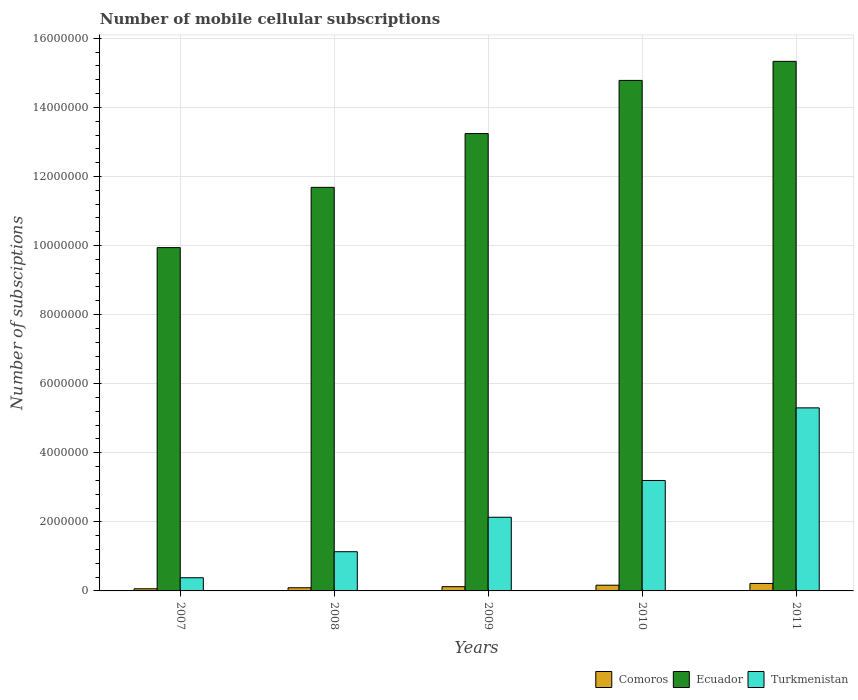How many groups of bars are there?
Give a very brief answer. 5. Are the number of bars per tick equal to the number of legend labels?
Offer a very short reply. Yes. Are the number of bars on each tick of the X-axis equal?
Your answer should be compact. Yes. How many bars are there on the 4th tick from the left?
Provide a short and direct response. 3. How many bars are there on the 4th tick from the right?
Your response must be concise. 3. What is the number of mobile cellular subscriptions in Comoros in 2009?
Make the answer very short. 1.23e+05. Across all years, what is the maximum number of mobile cellular subscriptions in Ecuador?
Offer a terse response. 1.53e+07. Across all years, what is the minimum number of mobile cellular subscriptions in Turkmenistan?
Keep it short and to the point. 3.82e+05. What is the total number of mobile cellular subscriptions in Comoros in the graph?
Ensure brevity in your answer.  6.58e+05. What is the difference between the number of mobile cellular subscriptions in Ecuador in 2008 and that in 2011?
Offer a terse response. -3.65e+06. What is the difference between the number of mobile cellular subscriptions in Comoros in 2008 and the number of mobile cellular subscriptions in Turkmenistan in 2007?
Your response must be concise. -2.90e+05. What is the average number of mobile cellular subscriptions in Turkmenistan per year?
Your answer should be very brief. 2.43e+06. In the year 2010, what is the difference between the number of mobile cellular subscriptions in Comoros and number of mobile cellular subscriptions in Ecuador?
Your answer should be very brief. -1.46e+07. What is the ratio of the number of mobile cellular subscriptions in Comoros in 2007 to that in 2011?
Make the answer very short. 0.29. What is the difference between the highest and the second highest number of mobile cellular subscriptions in Comoros?
Your response must be concise. 5.12e+04. What is the difference between the highest and the lowest number of mobile cellular subscriptions in Ecuador?
Make the answer very short. 5.39e+06. In how many years, is the number of mobile cellular subscriptions in Ecuador greater than the average number of mobile cellular subscriptions in Ecuador taken over all years?
Provide a short and direct response. 3. Is the sum of the number of mobile cellular subscriptions in Turkmenistan in 2008 and 2010 greater than the maximum number of mobile cellular subscriptions in Comoros across all years?
Offer a terse response. Yes. What does the 3rd bar from the left in 2011 represents?
Your answer should be compact. Turkmenistan. What does the 2nd bar from the right in 2010 represents?
Offer a terse response. Ecuador. How many years are there in the graph?
Provide a short and direct response. 5. Are the values on the major ticks of Y-axis written in scientific E-notation?
Offer a terse response. No. Does the graph contain any zero values?
Your answer should be compact. No. What is the title of the graph?
Offer a very short reply. Number of mobile cellular subscriptions. Does "High income: nonOECD" appear as one of the legend labels in the graph?
Ensure brevity in your answer.  No. What is the label or title of the X-axis?
Give a very brief answer. Years. What is the label or title of the Y-axis?
Ensure brevity in your answer.  Number of subsciptions. What is the Number of subsciptions in Comoros in 2007?
Keep it short and to the point. 6.21e+04. What is the Number of subsciptions of Ecuador in 2007?
Your response must be concise. 9.94e+06. What is the Number of subsciptions in Turkmenistan in 2007?
Make the answer very short. 3.82e+05. What is the Number of subsciptions in Comoros in 2008?
Your response must be concise. 9.17e+04. What is the Number of subsciptions in Ecuador in 2008?
Offer a very short reply. 1.17e+07. What is the Number of subsciptions of Turkmenistan in 2008?
Provide a succinct answer. 1.14e+06. What is the Number of subsciptions of Comoros in 2009?
Your answer should be very brief. 1.23e+05. What is the Number of subsciptions of Ecuador in 2009?
Your answer should be compact. 1.32e+07. What is the Number of subsciptions of Turkmenistan in 2009?
Your answer should be compact. 2.13e+06. What is the Number of subsciptions in Comoros in 2010?
Provide a succinct answer. 1.65e+05. What is the Number of subsciptions of Ecuador in 2010?
Offer a very short reply. 1.48e+07. What is the Number of subsciptions in Turkmenistan in 2010?
Offer a terse response. 3.20e+06. What is the Number of subsciptions in Comoros in 2011?
Your response must be concise. 2.16e+05. What is the Number of subsciptions in Ecuador in 2011?
Ensure brevity in your answer.  1.53e+07. What is the Number of subsciptions in Turkmenistan in 2011?
Make the answer very short. 5.30e+06. Across all years, what is the maximum Number of subsciptions in Comoros?
Keep it short and to the point. 2.16e+05. Across all years, what is the maximum Number of subsciptions in Ecuador?
Give a very brief answer. 1.53e+07. Across all years, what is the maximum Number of subsciptions of Turkmenistan?
Keep it short and to the point. 5.30e+06. Across all years, what is the minimum Number of subsciptions of Comoros?
Your answer should be very brief. 6.21e+04. Across all years, what is the minimum Number of subsciptions in Ecuador?
Your answer should be very brief. 9.94e+06. Across all years, what is the minimum Number of subsciptions of Turkmenistan?
Offer a very short reply. 3.82e+05. What is the total Number of subsciptions of Comoros in the graph?
Keep it short and to the point. 6.58e+05. What is the total Number of subsciptions in Ecuador in the graph?
Provide a short and direct response. 6.50e+07. What is the total Number of subsciptions of Turkmenistan in the graph?
Your answer should be very brief. 1.21e+07. What is the difference between the Number of subsciptions of Comoros in 2007 and that in 2008?
Provide a succinct answer. -2.96e+04. What is the difference between the Number of subsciptions of Ecuador in 2007 and that in 2008?
Your answer should be very brief. -1.74e+06. What is the difference between the Number of subsciptions in Turkmenistan in 2007 and that in 2008?
Offer a very short reply. -7.53e+05. What is the difference between the Number of subsciptions in Comoros in 2007 and that in 2009?
Your response must be concise. -6.05e+04. What is the difference between the Number of subsciptions of Ecuador in 2007 and that in 2009?
Your response must be concise. -3.30e+06. What is the difference between the Number of subsciptions in Turkmenistan in 2007 and that in 2009?
Your answer should be compact. -1.75e+06. What is the difference between the Number of subsciptions in Comoros in 2007 and that in 2010?
Make the answer very short. -1.03e+05. What is the difference between the Number of subsciptions in Ecuador in 2007 and that in 2010?
Ensure brevity in your answer.  -4.84e+06. What is the difference between the Number of subsciptions in Turkmenistan in 2007 and that in 2010?
Offer a very short reply. -2.82e+06. What is the difference between the Number of subsciptions of Comoros in 2007 and that in 2011?
Offer a very short reply. -1.54e+05. What is the difference between the Number of subsciptions in Ecuador in 2007 and that in 2011?
Provide a short and direct response. -5.39e+06. What is the difference between the Number of subsciptions in Turkmenistan in 2007 and that in 2011?
Your response must be concise. -4.92e+06. What is the difference between the Number of subsciptions of Comoros in 2008 and that in 2009?
Keep it short and to the point. -3.09e+04. What is the difference between the Number of subsciptions in Ecuador in 2008 and that in 2009?
Provide a succinct answer. -1.56e+06. What is the difference between the Number of subsciptions in Turkmenistan in 2008 and that in 2009?
Your answer should be very brief. -9.98e+05. What is the difference between the Number of subsciptions of Comoros in 2008 and that in 2010?
Your answer should be compact. -7.35e+04. What is the difference between the Number of subsciptions of Ecuador in 2008 and that in 2010?
Your response must be concise. -3.10e+06. What is the difference between the Number of subsciptions of Turkmenistan in 2008 and that in 2010?
Provide a succinct answer. -2.06e+06. What is the difference between the Number of subsciptions of Comoros in 2008 and that in 2011?
Give a very brief answer. -1.25e+05. What is the difference between the Number of subsciptions of Ecuador in 2008 and that in 2011?
Offer a very short reply. -3.65e+06. What is the difference between the Number of subsciptions in Turkmenistan in 2008 and that in 2011?
Make the answer very short. -4.16e+06. What is the difference between the Number of subsciptions in Comoros in 2009 and that in 2010?
Ensure brevity in your answer.  -4.27e+04. What is the difference between the Number of subsciptions in Ecuador in 2009 and that in 2010?
Keep it short and to the point. -1.54e+06. What is the difference between the Number of subsciptions of Turkmenistan in 2009 and that in 2010?
Make the answer very short. -1.06e+06. What is the difference between the Number of subsciptions in Comoros in 2009 and that in 2011?
Give a very brief answer. -9.38e+04. What is the difference between the Number of subsciptions of Ecuador in 2009 and that in 2011?
Offer a very short reply. -2.09e+06. What is the difference between the Number of subsciptions in Turkmenistan in 2009 and that in 2011?
Give a very brief answer. -3.17e+06. What is the difference between the Number of subsciptions of Comoros in 2010 and that in 2011?
Your answer should be very brief. -5.12e+04. What is the difference between the Number of subsciptions in Ecuador in 2010 and that in 2011?
Your answer should be very brief. -5.52e+05. What is the difference between the Number of subsciptions in Turkmenistan in 2010 and that in 2011?
Your response must be concise. -2.10e+06. What is the difference between the Number of subsciptions in Comoros in 2007 and the Number of subsciptions in Ecuador in 2008?
Offer a very short reply. -1.16e+07. What is the difference between the Number of subsciptions of Comoros in 2007 and the Number of subsciptions of Turkmenistan in 2008?
Give a very brief answer. -1.07e+06. What is the difference between the Number of subsciptions in Ecuador in 2007 and the Number of subsciptions in Turkmenistan in 2008?
Your answer should be very brief. 8.80e+06. What is the difference between the Number of subsciptions of Comoros in 2007 and the Number of subsciptions of Ecuador in 2009?
Keep it short and to the point. -1.32e+07. What is the difference between the Number of subsciptions of Comoros in 2007 and the Number of subsciptions of Turkmenistan in 2009?
Make the answer very short. -2.07e+06. What is the difference between the Number of subsciptions of Ecuador in 2007 and the Number of subsciptions of Turkmenistan in 2009?
Make the answer very short. 7.81e+06. What is the difference between the Number of subsciptions in Comoros in 2007 and the Number of subsciptions in Ecuador in 2010?
Offer a very short reply. -1.47e+07. What is the difference between the Number of subsciptions in Comoros in 2007 and the Number of subsciptions in Turkmenistan in 2010?
Offer a very short reply. -3.14e+06. What is the difference between the Number of subsciptions in Ecuador in 2007 and the Number of subsciptions in Turkmenistan in 2010?
Offer a terse response. 6.74e+06. What is the difference between the Number of subsciptions of Comoros in 2007 and the Number of subsciptions of Ecuador in 2011?
Ensure brevity in your answer.  -1.53e+07. What is the difference between the Number of subsciptions of Comoros in 2007 and the Number of subsciptions of Turkmenistan in 2011?
Your response must be concise. -5.24e+06. What is the difference between the Number of subsciptions of Ecuador in 2007 and the Number of subsciptions of Turkmenistan in 2011?
Keep it short and to the point. 4.64e+06. What is the difference between the Number of subsciptions in Comoros in 2008 and the Number of subsciptions in Ecuador in 2009?
Make the answer very short. -1.32e+07. What is the difference between the Number of subsciptions in Comoros in 2008 and the Number of subsciptions in Turkmenistan in 2009?
Give a very brief answer. -2.04e+06. What is the difference between the Number of subsciptions of Ecuador in 2008 and the Number of subsciptions of Turkmenistan in 2009?
Your response must be concise. 9.55e+06. What is the difference between the Number of subsciptions of Comoros in 2008 and the Number of subsciptions of Ecuador in 2010?
Your answer should be compact. -1.47e+07. What is the difference between the Number of subsciptions in Comoros in 2008 and the Number of subsciptions in Turkmenistan in 2010?
Your answer should be compact. -3.11e+06. What is the difference between the Number of subsciptions of Ecuador in 2008 and the Number of subsciptions of Turkmenistan in 2010?
Your answer should be very brief. 8.49e+06. What is the difference between the Number of subsciptions in Comoros in 2008 and the Number of subsciptions in Ecuador in 2011?
Offer a terse response. -1.52e+07. What is the difference between the Number of subsciptions in Comoros in 2008 and the Number of subsciptions in Turkmenistan in 2011?
Ensure brevity in your answer.  -5.21e+06. What is the difference between the Number of subsciptions in Ecuador in 2008 and the Number of subsciptions in Turkmenistan in 2011?
Provide a succinct answer. 6.38e+06. What is the difference between the Number of subsciptions of Comoros in 2009 and the Number of subsciptions of Ecuador in 2010?
Ensure brevity in your answer.  -1.47e+07. What is the difference between the Number of subsciptions of Comoros in 2009 and the Number of subsciptions of Turkmenistan in 2010?
Provide a short and direct response. -3.08e+06. What is the difference between the Number of subsciptions of Ecuador in 2009 and the Number of subsciptions of Turkmenistan in 2010?
Your answer should be compact. 1.00e+07. What is the difference between the Number of subsciptions in Comoros in 2009 and the Number of subsciptions in Ecuador in 2011?
Provide a short and direct response. -1.52e+07. What is the difference between the Number of subsciptions in Comoros in 2009 and the Number of subsciptions in Turkmenistan in 2011?
Provide a succinct answer. -5.18e+06. What is the difference between the Number of subsciptions of Ecuador in 2009 and the Number of subsciptions of Turkmenistan in 2011?
Offer a terse response. 7.94e+06. What is the difference between the Number of subsciptions of Comoros in 2010 and the Number of subsciptions of Ecuador in 2011?
Make the answer very short. -1.52e+07. What is the difference between the Number of subsciptions of Comoros in 2010 and the Number of subsciptions of Turkmenistan in 2011?
Your answer should be very brief. -5.13e+06. What is the difference between the Number of subsciptions in Ecuador in 2010 and the Number of subsciptions in Turkmenistan in 2011?
Give a very brief answer. 9.48e+06. What is the average Number of subsciptions in Comoros per year?
Make the answer very short. 1.32e+05. What is the average Number of subsciptions of Ecuador per year?
Your answer should be compact. 1.30e+07. What is the average Number of subsciptions in Turkmenistan per year?
Your response must be concise. 2.43e+06. In the year 2007, what is the difference between the Number of subsciptions of Comoros and Number of subsciptions of Ecuador?
Your answer should be very brief. -9.88e+06. In the year 2007, what is the difference between the Number of subsciptions in Comoros and Number of subsciptions in Turkmenistan?
Ensure brevity in your answer.  -3.20e+05. In the year 2007, what is the difference between the Number of subsciptions of Ecuador and Number of subsciptions of Turkmenistan?
Give a very brief answer. 9.56e+06. In the year 2008, what is the difference between the Number of subsciptions of Comoros and Number of subsciptions of Ecuador?
Provide a succinct answer. -1.16e+07. In the year 2008, what is the difference between the Number of subsciptions in Comoros and Number of subsciptions in Turkmenistan?
Provide a succinct answer. -1.04e+06. In the year 2008, what is the difference between the Number of subsciptions of Ecuador and Number of subsciptions of Turkmenistan?
Make the answer very short. 1.05e+07. In the year 2009, what is the difference between the Number of subsciptions in Comoros and Number of subsciptions in Ecuador?
Your answer should be very brief. -1.31e+07. In the year 2009, what is the difference between the Number of subsciptions of Comoros and Number of subsciptions of Turkmenistan?
Offer a terse response. -2.01e+06. In the year 2009, what is the difference between the Number of subsciptions of Ecuador and Number of subsciptions of Turkmenistan?
Make the answer very short. 1.11e+07. In the year 2010, what is the difference between the Number of subsciptions in Comoros and Number of subsciptions in Ecuador?
Ensure brevity in your answer.  -1.46e+07. In the year 2010, what is the difference between the Number of subsciptions of Comoros and Number of subsciptions of Turkmenistan?
Offer a very short reply. -3.03e+06. In the year 2010, what is the difference between the Number of subsciptions of Ecuador and Number of subsciptions of Turkmenistan?
Ensure brevity in your answer.  1.16e+07. In the year 2011, what is the difference between the Number of subsciptions in Comoros and Number of subsciptions in Ecuador?
Offer a very short reply. -1.51e+07. In the year 2011, what is the difference between the Number of subsciptions of Comoros and Number of subsciptions of Turkmenistan?
Give a very brief answer. -5.08e+06. In the year 2011, what is the difference between the Number of subsciptions in Ecuador and Number of subsciptions in Turkmenistan?
Your answer should be very brief. 1.00e+07. What is the ratio of the Number of subsciptions in Comoros in 2007 to that in 2008?
Offer a terse response. 0.68. What is the ratio of the Number of subsciptions of Ecuador in 2007 to that in 2008?
Provide a short and direct response. 0.85. What is the ratio of the Number of subsciptions in Turkmenistan in 2007 to that in 2008?
Keep it short and to the point. 0.34. What is the ratio of the Number of subsciptions in Comoros in 2007 to that in 2009?
Give a very brief answer. 0.51. What is the ratio of the Number of subsciptions of Ecuador in 2007 to that in 2009?
Your answer should be very brief. 0.75. What is the ratio of the Number of subsciptions of Turkmenistan in 2007 to that in 2009?
Provide a short and direct response. 0.18. What is the ratio of the Number of subsciptions in Comoros in 2007 to that in 2010?
Give a very brief answer. 0.38. What is the ratio of the Number of subsciptions in Ecuador in 2007 to that in 2010?
Give a very brief answer. 0.67. What is the ratio of the Number of subsciptions of Turkmenistan in 2007 to that in 2010?
Ensure brevity in your answer.  0.12. What is the ratio of the Number of subsciptions in Comoros in 2007 to that in 2011?
Provide a short and direct response. 0.29. What is the ratio of the Number of subsciptions in Ecuador in 2007 to that in 2011?
Offer a very short reply. 0.65. What is the ratio of the Number of subsciptions in Turkmenistan in 2007 to that in 2011?
Provide a short and direct response. 0.07. What is the ratio of the Number of subsciptions of Comoros in 2008 to that in 2009?
Your response must be concise. 0.75. What is the ratio of the Number of subsciptions of Ecuador in 2008 to that in 2009?
Your answer should be compact. 0.88. What is the ratio of the Number of subsciptions of Turkmenistan in 2008 to that in 2009?
Give a very brief answer. 0.53. What is the ratio of the Number of subsciptions in Comoros in 2008 to that in 2010?
Make the answer very short. 0.56. What is the ratio of the Number of subsciptions of Ecuador in 2008 to that in 2010?
Keep it short and to the point. 0.79. What is the ratio of the Number of subsciptions in Turkmenistan in 2008 to that in 2010?
Provide a short and direct response. 0.35. What is the ratio of the Number of subsciptions of Comoros in 2008 to that in 2011?
Your answer should be compact. 0.42. What is the ratio of the Number of subsciptions in Ecuador in 2008 to that in 2011?
Your response must be concise. 0.76. What is the ratio of the Number of subsciptions of Turkmenistan in 2008 to that in 2011?
Your answer should be compact. 0.21. What is the ratio of the Number of subsciptions in Comoros in 2009 to that in 2010?
Provide a short and direct response. 0.74. What is the ratio of the Number of subsciptions of Ecuador in 2009 to that in 2010?
Give a very brief answer. 0.9. What is the ratio of the Number of subsciptions of Turkmenistan in 2009 to that in 2010?
Offer a terse response. 0.67. What is the ratio of the Number of subsciptions of Comoros in 2009 to that in 2011?
Your response must be concise. 0.57. What is the ratio of the Number of subsciptions in Ecuador in 2009 to that in 2011?
Give a very brief answer. 0.86. What is the ratio of the Number of subsciptions in Turkmenistan in 2009 to that in 2011?
Give a very brief answer. 0.4. What is the ratio of the Number of subsciptions in Comoros in 2010 to that in 2011?
Ensure brevity in your answer.  0.76. What is the ratio of the Number of subsciptions of Turkmenistan in 2010 to that in 2011?
Provide a succinct answer. 0.6. What is the difference between the highest and the second highest Number of subsciptions of Comoros?
Your answer should be compact. 5.12e+04. What is the difference between the highest and the second highest Number of subsciptions in Ecuador?
Provide a succinct answer. 5.52e+05. What is the difference between the highest and the second highest Number of subsciptions in Turkmenistan?
Provide a short and direct response. 2.10e+06. What is the difference between the highest and the lowest Number of subsciptions in Comoros?
Offer a very short reply. 1.54e+05. What is the difference between the highest and the lowest Number of subsciptions of Ecuador?
Ensure brevity in your answer.  5.39e+06. What is the difference between the highest and the lowest Number of subsciptions in Turkmenistan?
Give a very brief answer. 4.92e+06. 